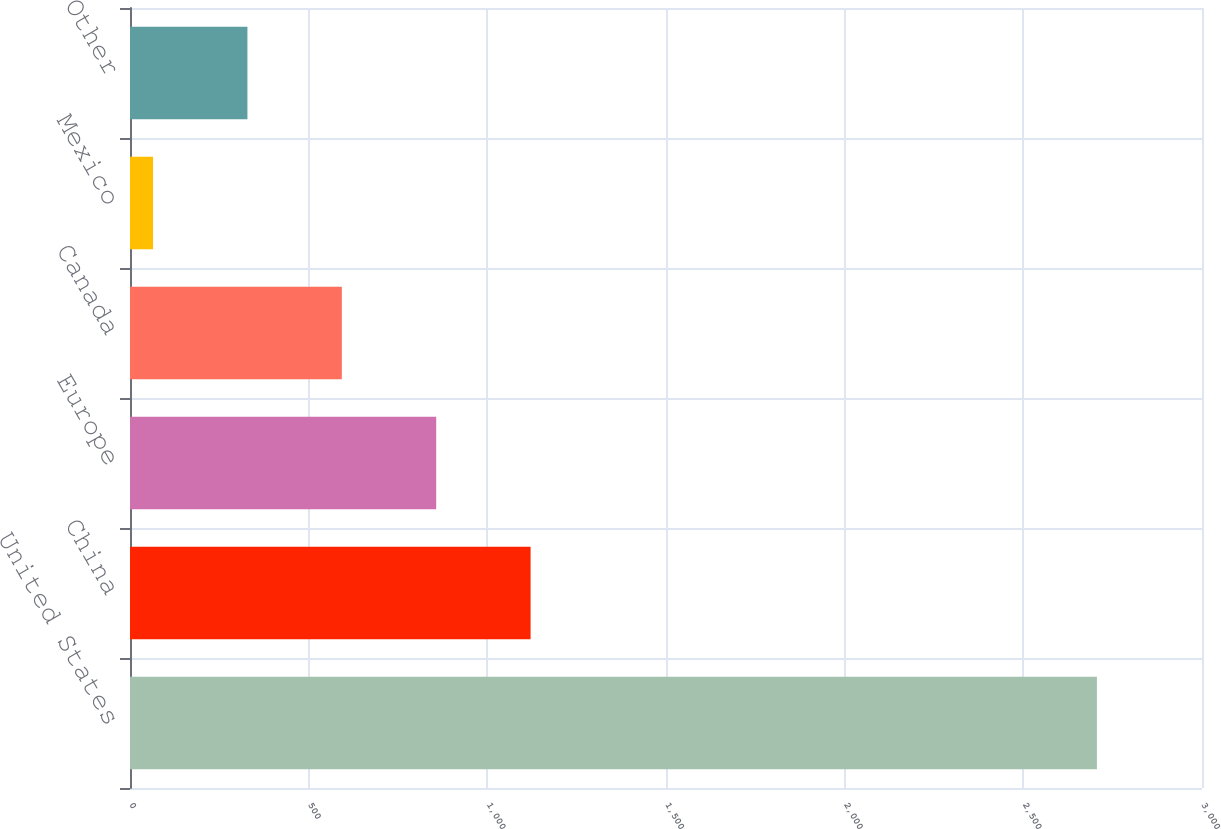Convert chart. <chart><loc_0><loc_0><loc_500><loc_500><bar_chart><fcel>United States<fcel>China<fcel>Europe<fcel>Canada<fcel>Mexico<fcel>Other<nl><fcel>2705.9<fcel>1121.06<fcel>856.92<fcel>592.78<fcel>64.5<fcel>328.64<nl></chart> 